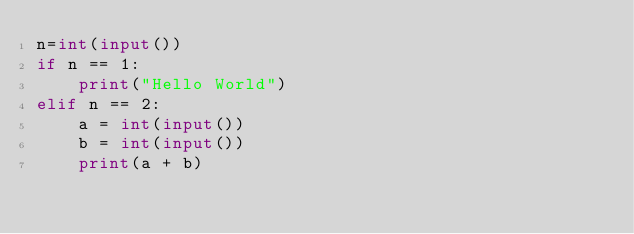Convert code to text. <code><loc_0><loc_0><loc_500><loc_500><_Python_>n=int(input())
if n == 1:
    print("Hello World")
elif n == 2:
    a = int(input())
    b = int(input())
    print(a + b)</code> 